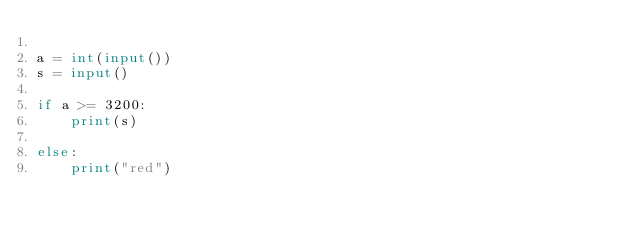Convert code to text. <code><loc_0><loc_0><loc_500><loc_500><_Python_>
a = int(input())
s = input()

if a >= 3200:
    print(s)

else:
    print("red")</code> 